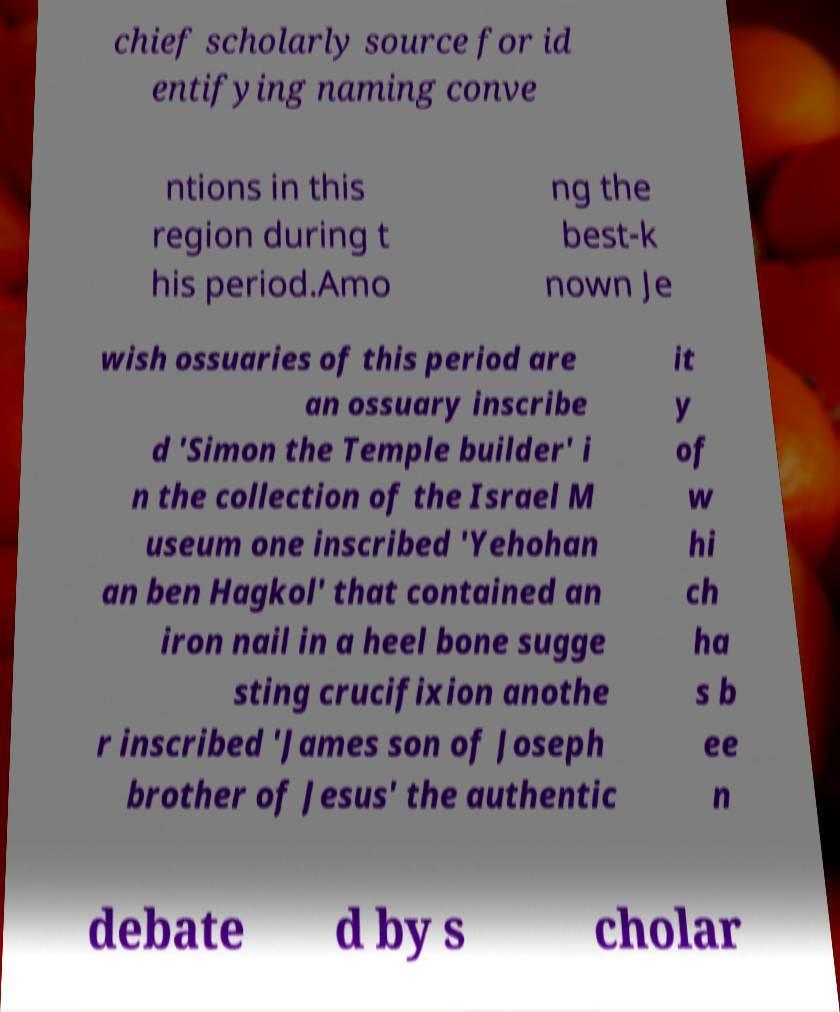Can you read and provide the text displayed in the image?This photo seems to have some interesting text. Can you extract and type it out for me? chief scholarly source for id entifying naming conve ntions in this region during t his period.Amo ng the best-k nown Je wish ossuaries of this period are an ossuary inscribe d 'Simon the Temple builder' i n the collection of the Israel M useum one inscribed 'Yehohan an ben Hagkol' that contained an iron nail in a heel bone sugge sting crucifixion anothe r inscribed 'James son of Joseph brother of Jesus' the authentic it y of w hi ch ha s b ee n debate d by s cholar 